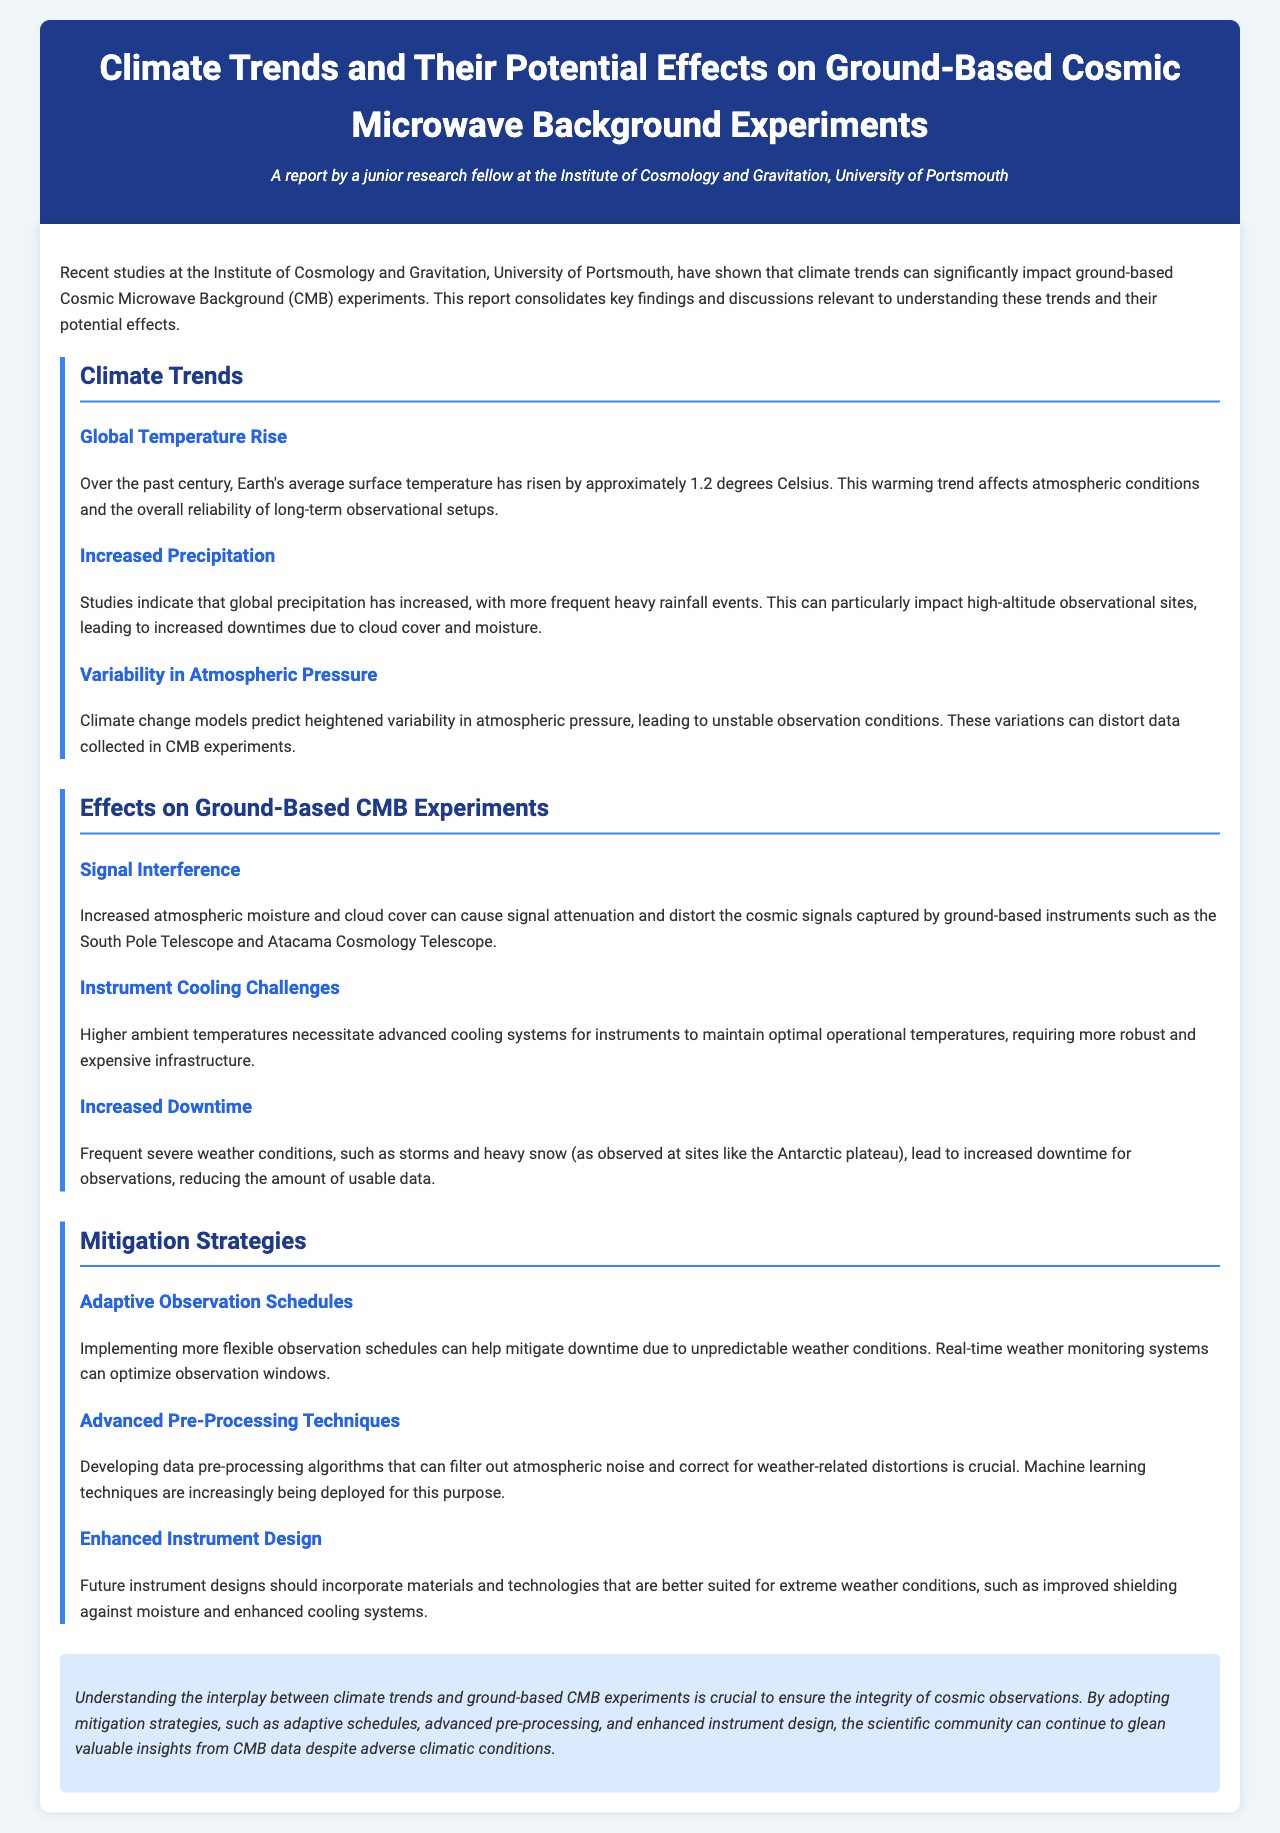What is the average global temperature rise over the past century? The document states that Earth's average surface temperature has risen by approximately 1.2 degrees Celsius.
Answer: 1.2 degrees Celsius What is one consequence of increased precipitation for observational sites? Increased precipitation leads to more frequent heavy rainfall events which can increase downtimes due to cloud cover and moisture at high-altitude observational sites.
Answer: Increased downtimes What can heightened variability in atmospheric pressure cause? It can lead to unstable observation conditions, which may distort data collected in CMB experiments.
Answer: Unstable observation conditions Which observation telescope is mentioned in the context of signal interference? The South Pole Telescope is mentioned as affected by signal attenuation due to increased atmospheric moisture.
Answer: South Pole Telescope What strategy can help mitigate downtime due to weather? Implementing more flexible observation schedules can help mitigate downtime caused by unpredictable weather conditions.
Answer: Flexible observation schedules What is one proposed solution for enhancing the design of future instruments? Future instrument designs should incorporate materials that are better suited for extreme weather conditions.
Answer: Better suited materials What technological method is being deployed to filter out atmospheric noise? Machine learning techniques are increasingly being deployed for filtering out atmospheric noise in data pre-processing.
Answer: Machine learning techniques What is the focus of the document? The document focuses on the impact of climate trends on ground-based Cosmic Microwave Background experiments and relevant mitigation strategies.
Answer: Climate trends' impact on CMB experiments 